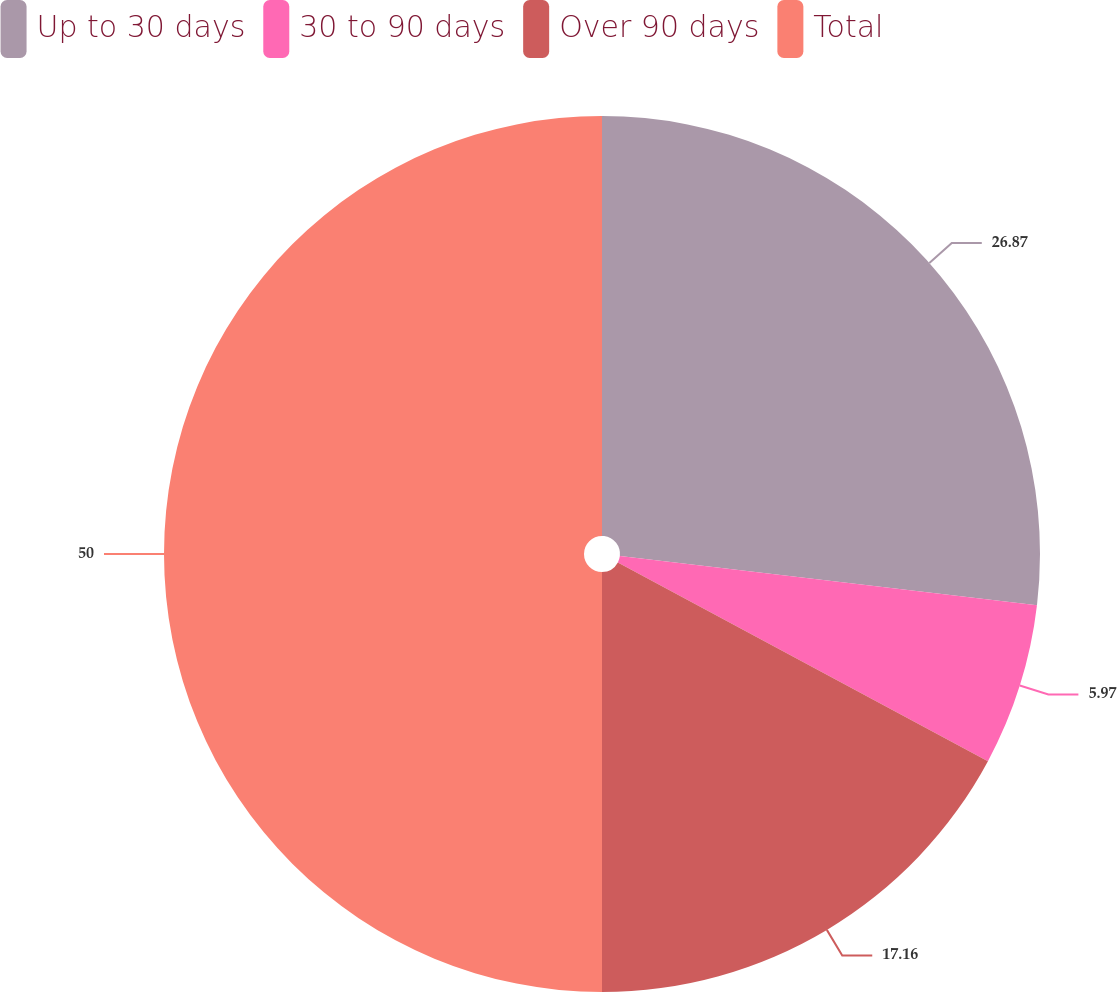Convert chart. <chart><loc_0><loc_0><loc_500><loc_500><pie_chart><fcel>Up to 30 days<fcel>30 to 90 days<fcel>Over 90 days<fcel>Total<nl><fcel>26.87%<fcel>5.97%<fcel>17.16%<fcel>50.0%<nl></chart> 